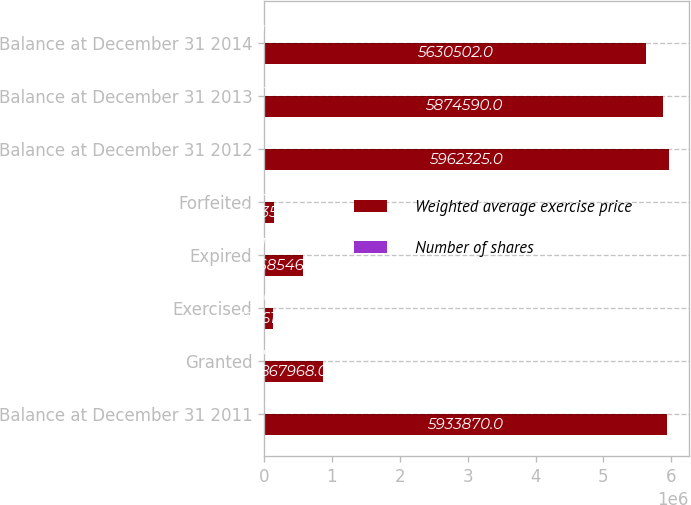Convert chart to OTSL. <chart><loc_0><loc_0><loc_500><loc_500><stacked_bar_chart><ecel><fcel>Balance at December 31 2011<fcel>Granted<fcel>Exercised<fcel>Expired<fcel>Forfeited<fcel>Balance at December 31 2012<fcel>Balance at December 31 2013<fcel>Balance at December 31 2014<nl><fcel>Weighted average exercise price<fcel>5.93387e+06<fcel>867968<fcel>129616<fcel>568546<fcel>141351<fcel>5.96232e+06<fcel>5.87459e+06<fcel>5.6305e+06<nl><fcel>Number of shares<fcel>43.06<fcel>18.87<fcel>14.64<fcel>61.9<fcel>21.36<fcel>38.87<fcel>35.54<fcel>31.6<nl></chart> 